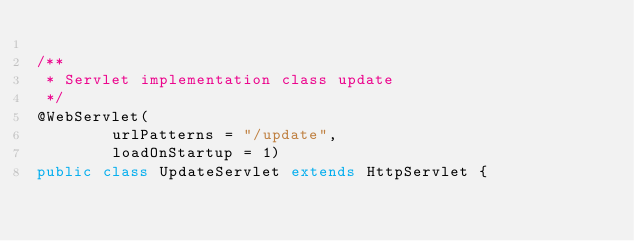<code> <loc_0><loc_0><loc_500><loc_500><_Java_>
/**
 * Servlet implementation class update
 */
@WebServlet(
		urlPatterns = "/update",
		loadOnStartup = 1)
public class UpdateServlet extends HttpServlet {
	</code> 